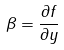<formula> <loc_0><loc_0><loc_500><loc_500>\beta = \frac { \partial f } { \partial y }</formula> 